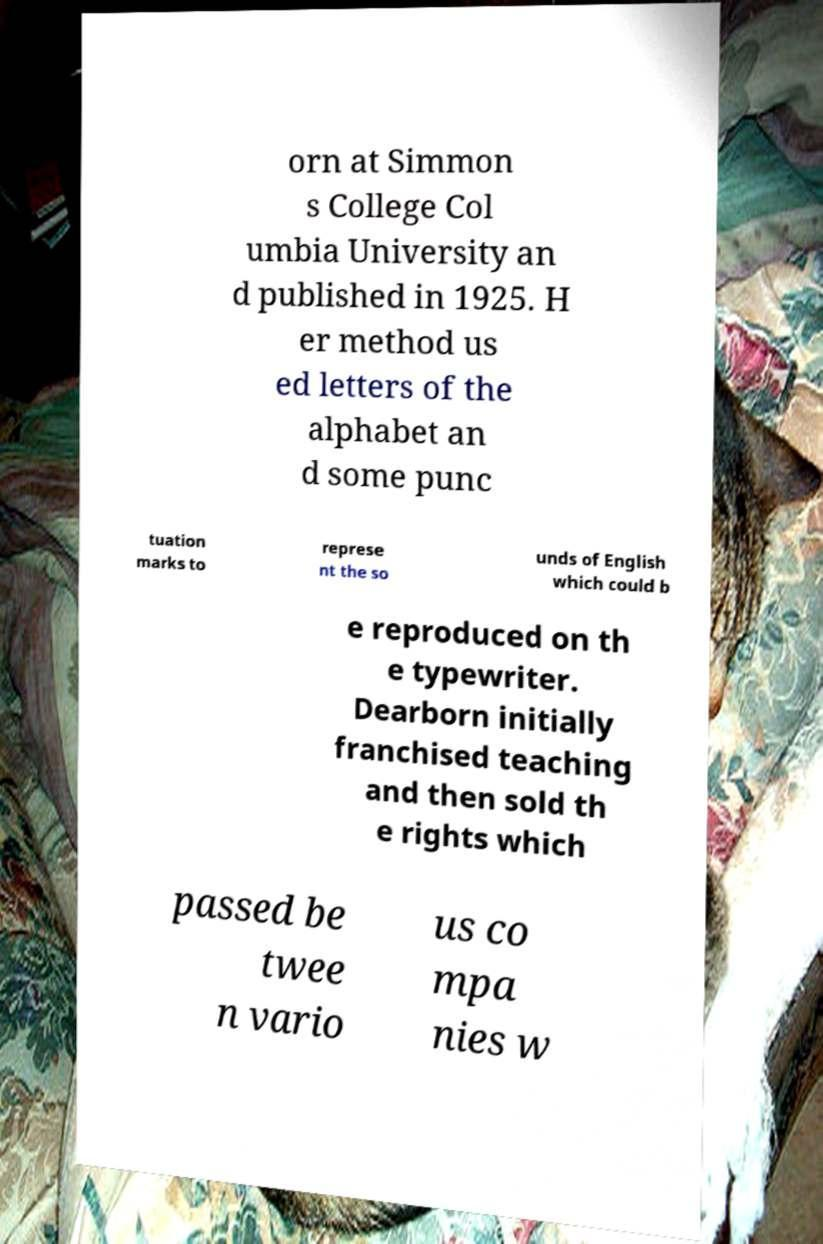Can you accurately transcribe the text from the provided image for me? orn at Simmon s College Col umbia University an d published in 1925. H er method us ed letters of the alphabet an d some punc tuation marks to represe nt the so unds of English which could b e reproduced on th e typewriter. Dearborn initially franchised teaching and then sold th e rights which passed be twee n vario us co mpa nies w 